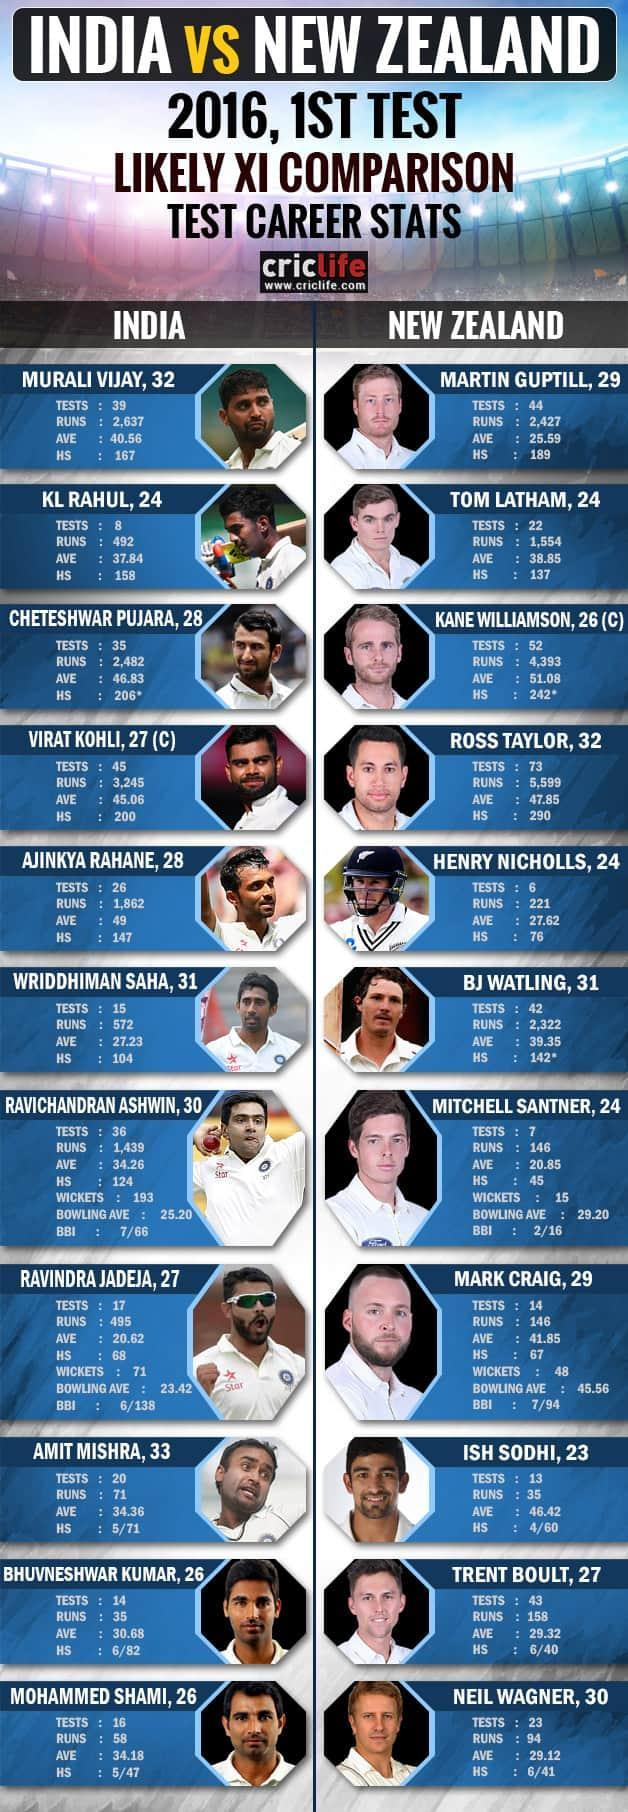How many players in this infographic with an average of more than 50?
Answer the question with a short phrase. 3 How many players in this infographic with age 28? 2 How many players in this infographic with age 30? 2 How many players in this infographic with runs more than 2000? 7 How many players in this infographic with tests more than 50? 2 